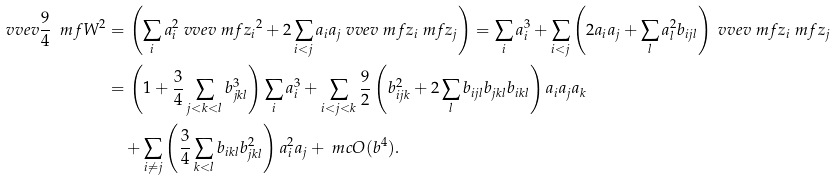<formula> <loc_0><loc_0><loc_500><loc_500>\ v v e v { \frac { 9 } { 4 } \ m f { W } ^ { 2 } } & = \left ( \sum _ { i } a _ { i } ^ { 2 } \ v v e v { \ m f { z _ { i } } ^ { 2 } } + 2 \sum _ { i < j } a _ { i } a _ { j } \ v v e v { \ m f { z _ { i } } \ m f { z _ { j } } } \right ) = \sum _ { i } a _ { i } ^ { 3 } + \sum _ { i < j } \left ( 2 a _ { i } a _ { j } + \sum _ { l } a _ { l } ^ { 2 } b _ { i j l } \right ) \ v v e v { \ m f { z _ { i } } \ m f { z _ { j } } } \\ & = \left ( 1 + \frac { 3 } { 4 } \sum _ { j < k < l } b _ { j k l } ^ { 3 } \right ) \sum _ { i } a _ { i } ^ { 3 } + \sum _ { i < j < k } \frac { 9 } { 2 } \left ( b _ { i j k } ^ { 2 } + 2 \sum _ { l } b _ { i j l } b _ { j k l } b _ { i k l } \right ) a _ { i } a _ { j } a _ { k } \\ & \quad + \sum _ { i \neq j } \left ( \frac { 3 } { 4 } \sum _ { k < l } b _ { i k l } b _ { j k l } ^ { 2 } \right ) a _ { i } ^ { 2 } a _ { j } + \ m c O ( b ^ { 4 } ) .</formula> 